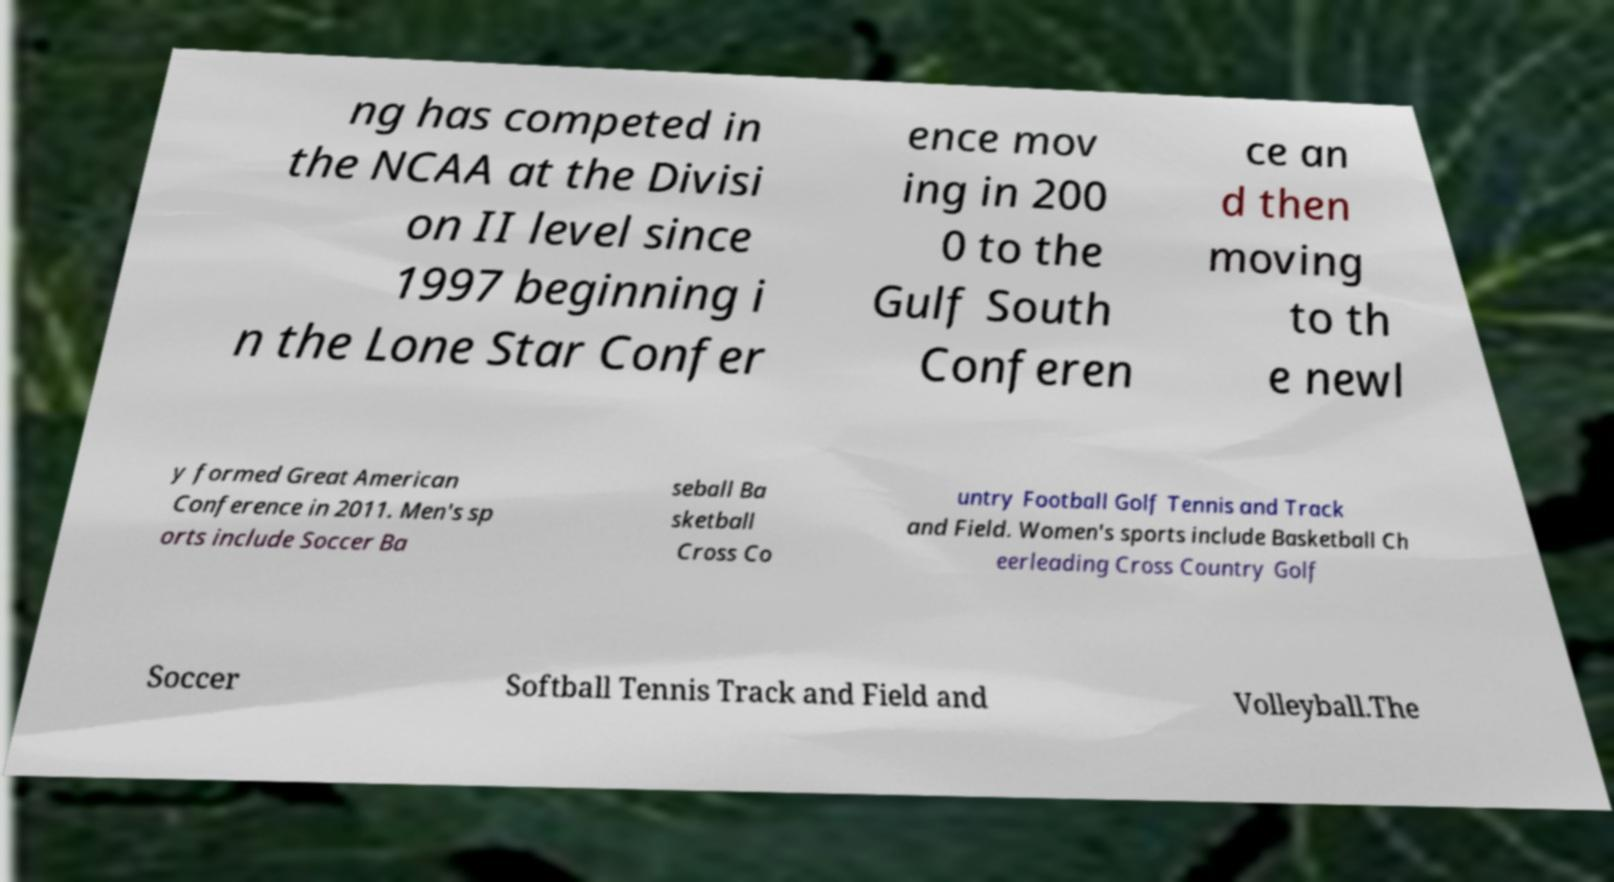Can you read and provide the text displayed in the image?This photo seems to have some interesting text. Can you extract and type it out for me? ng has competed in the NCAA at the Divisi on II level since 1997 beginning i n the Lone Star Confer ence mov ing in 200 0 to the Gulf South Conferen ce an d then moving to th e newl y formed Great American Conference in 2011. Men's sp orts include Soccer Ba seball Ba sketball Cross Co untry Football Golf Tennis and Track and Field. Women's sports include Basketball Ch eerleading Cross Country Golf Soccer Softball Tennis Track and Field and Volleyball.The 